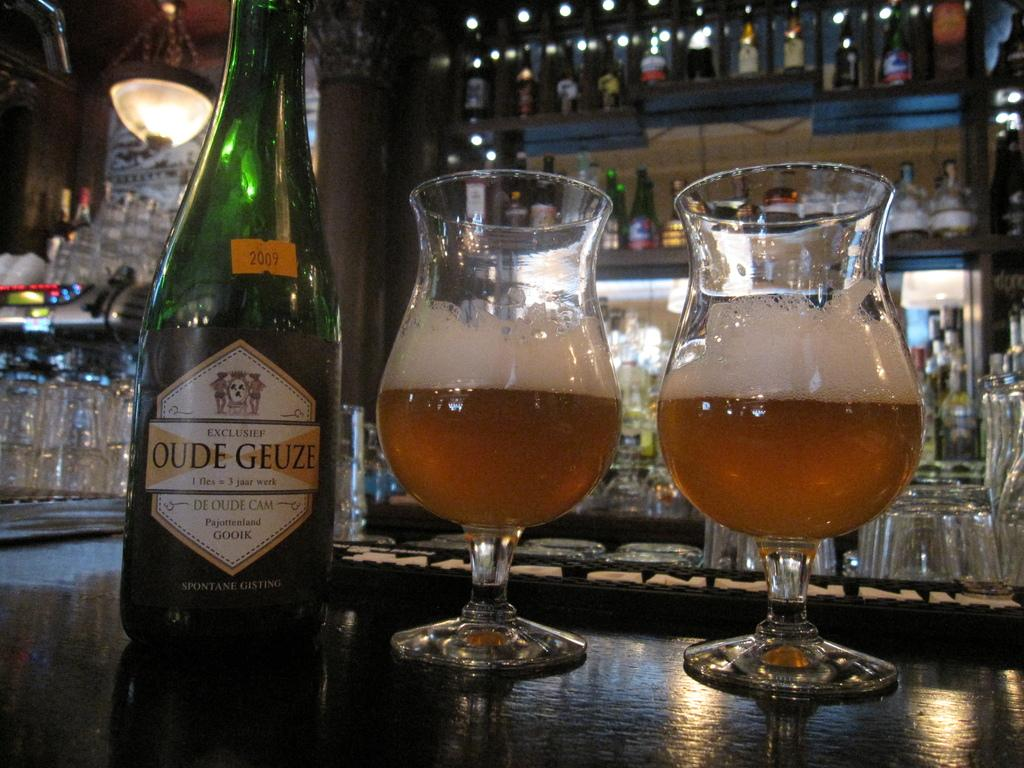What can be seen in the image that is used for holding liquids? There is a bottle in the image, and two wine glasses are on the table. What is unique about the bottle in the image? The bottle has a logo on it. What can be seen in the background of the image? There are many glasses, bottles, and racks in the background of the image. What type of guide is holding the balloon in the image? There is no guide or balloon present in the image. What is the cart used for in the image? There is no cart present in the image. 